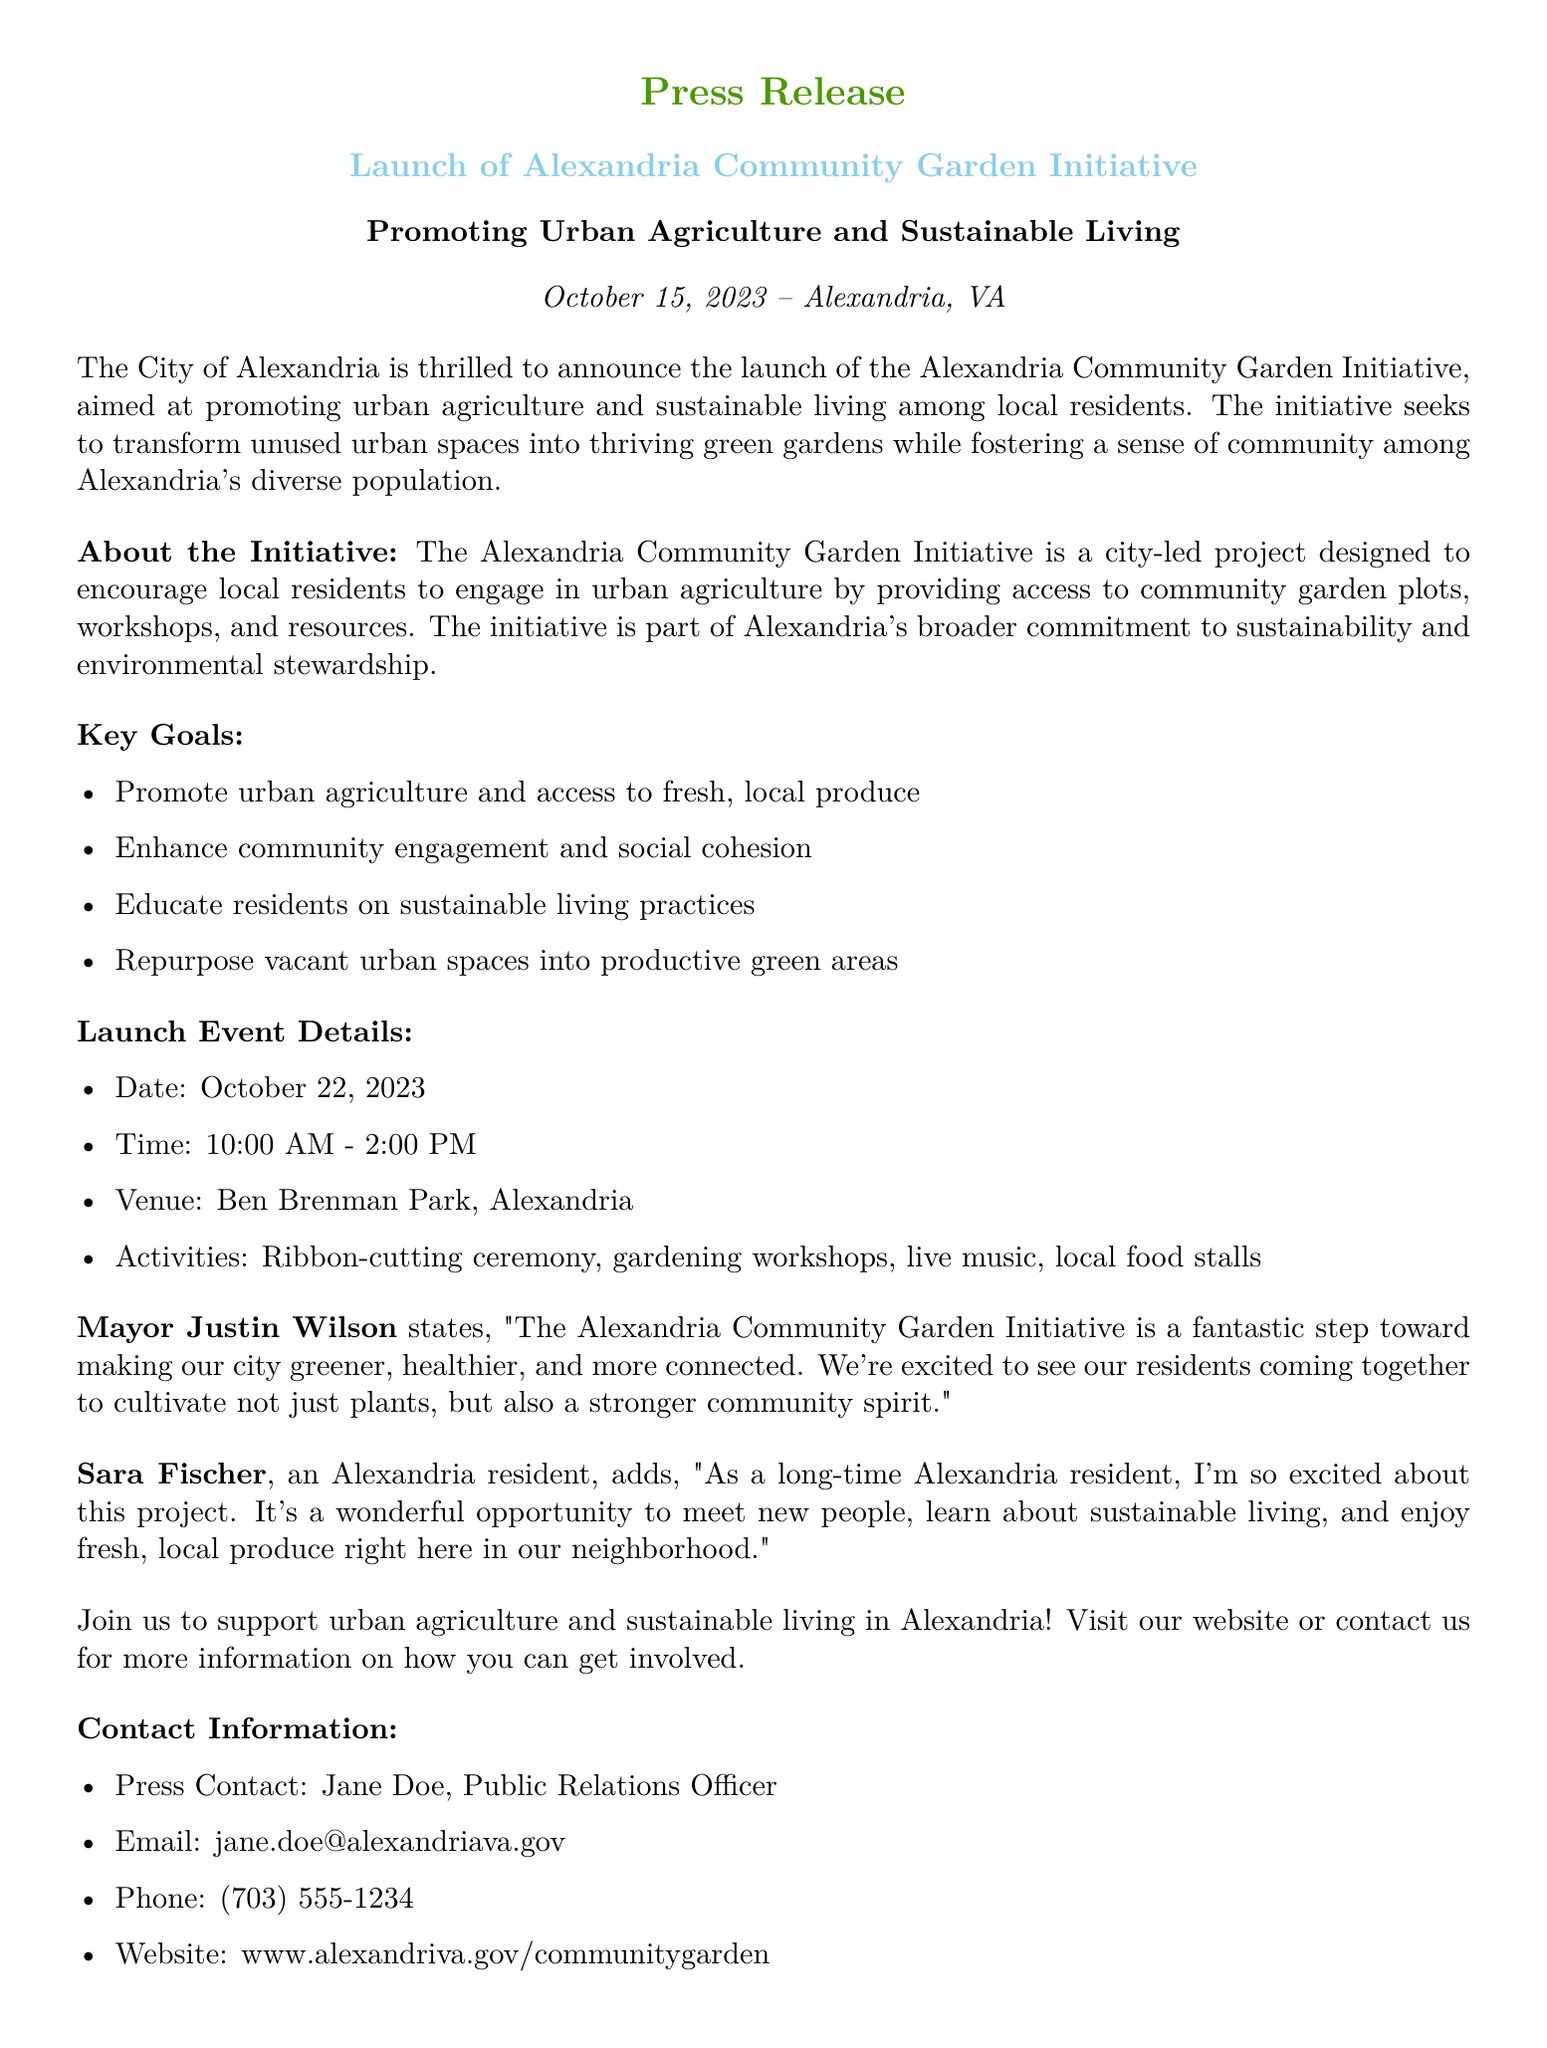What is the launch date of the initiative? The launch date of the Alexandria Community Garden Initiative is stated as October 22, 2023.
Answer: October 22, 2023 Where is the launch event taking place? The launch event will be held at Ben Brenman Park, Alexandria.
Answer: Ben Brenman Park, Alexandria What is the main goal of the initiative? The initiative's main goal includes promoting urban agriculture and access to fresh, local produce.
Answer: Promote urban agriculture and access to fresh, local produce Who is quoted in the press release? The press release includes quotes from Mayor Justin Wilson and resident Sara Fischer.
Answer: Mayor Justin Wilson and Sara Fischer What activities are planned for the launch event? The activities at the launch event include a ribbon-cutting ceremony, gardening workshops, live music, and local food stalls.
Answer: Ribbon-cutting ceremony, gardening workshops, live music, local food stalls What time does the launch event start? The starting time of the launch event is specified in the document as 10:00 AM.
Answer: 10:00 AM What does Sara Fischer express excitement about? Sara Fischer expresses excitement about meeting new people, learning about sustainable living, and enjoying fresh local produce.
Answer: Meeting new people, learning about sustainable living, enjoying fresh local produce What is the name of the Public Relations Officer? The name of the Public Relations Officer is listed as Jane Doe.
Answer: Jane Doe 